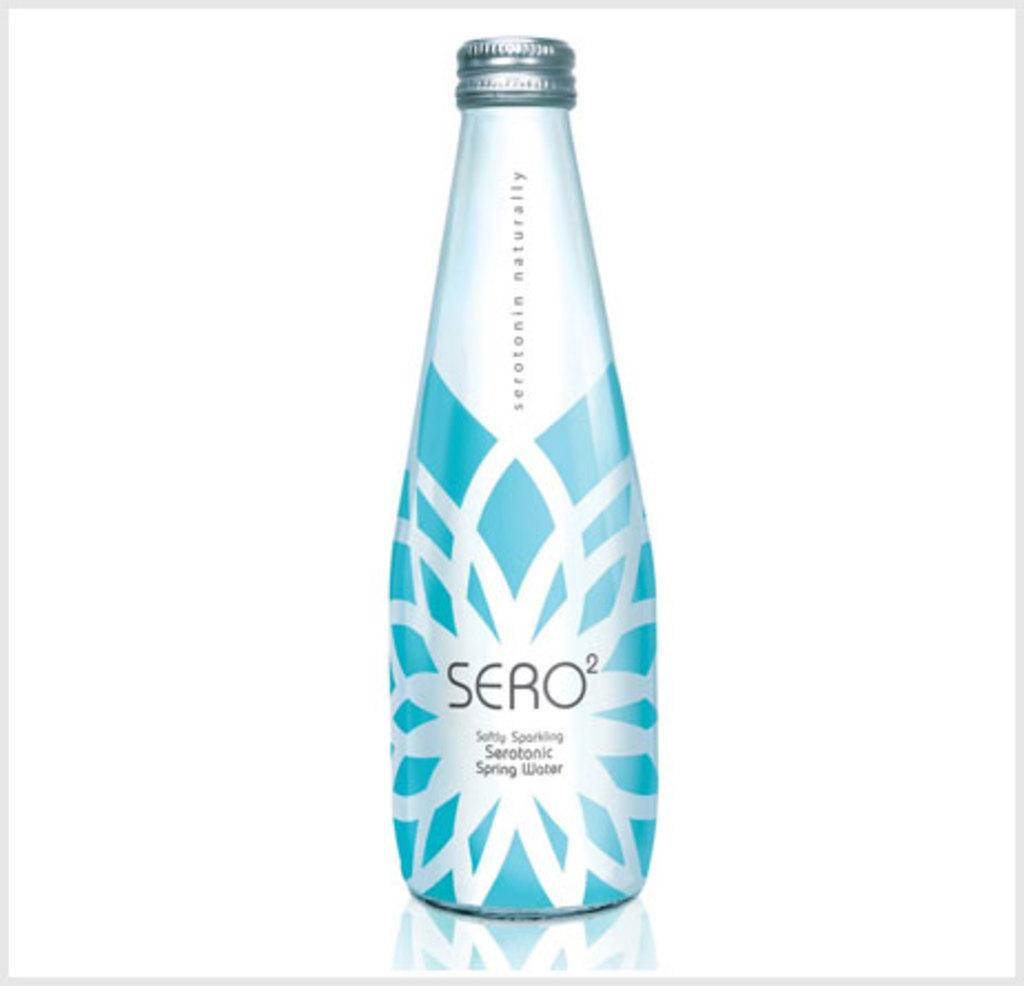<image>
Create a compact narrative representing the image presented. A bottle of spring water from the brand SERO. 